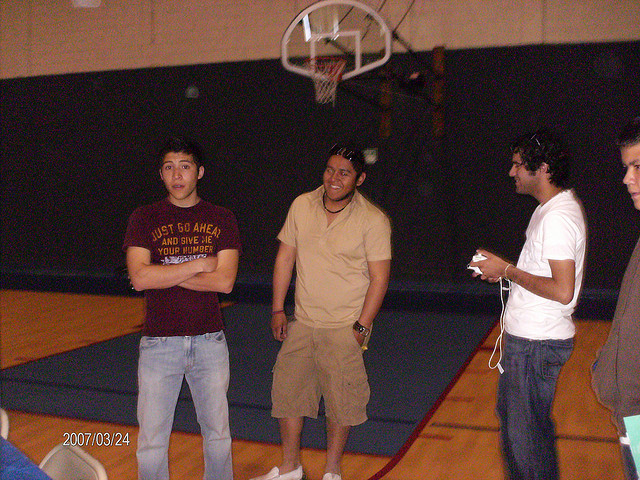How many kids are there? The image shows three individuals who appear to be young adults rather than kids, standing in a gymnasium with a basketball hoop in the background. 